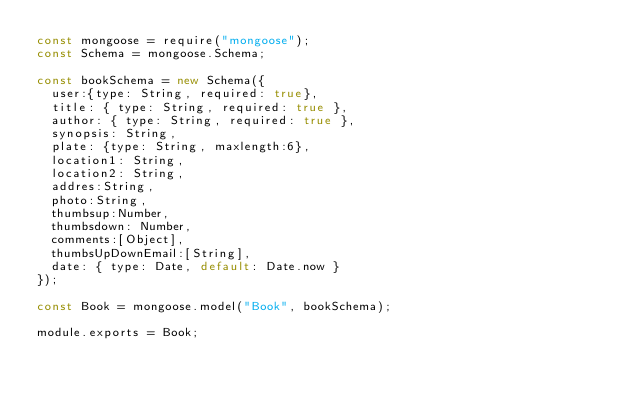<code> <loc_0><loc_0><loc_500><loc_500><_JavaScript_>const mongoose = require("mongoose");
const Schema = mongoose.Schema;

const bookSchema = new Schema({
  user:{type: String, required: true},
  title: { type: String, required: true },
  author: { type: String, required: true },
  synopsis: String,
  plate: {type: String, maxlength:6},
  location1: String,
  location2: String,
  addres:String,
  photo:String,
  thumbsup:Number,
  thumbsdown: Number,
  comments:[Object],
  thumbsUpDownEmail:[String],
  date: { type: Date, default: Date.now }
});

const Book = mongoose.model("Book", bookSchema);

module.exports = Book;
</code> 